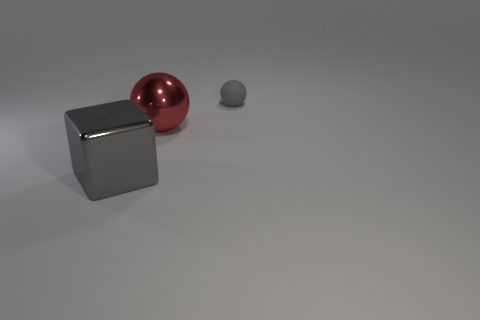Add 1 red spheres. How many objects exist? 4 Subtract all spheres. How many objects are left? 1 Subtract 1 gray spheres. How many objects are left? 2 Subtract all cyan cylinders. Subtract all small gray matte spheres. How many objects are left? 2 Add 3 big metal cubes. How many big metal cubes are left? 4 Add 3 shiny things. How many shiny things exist? 5 